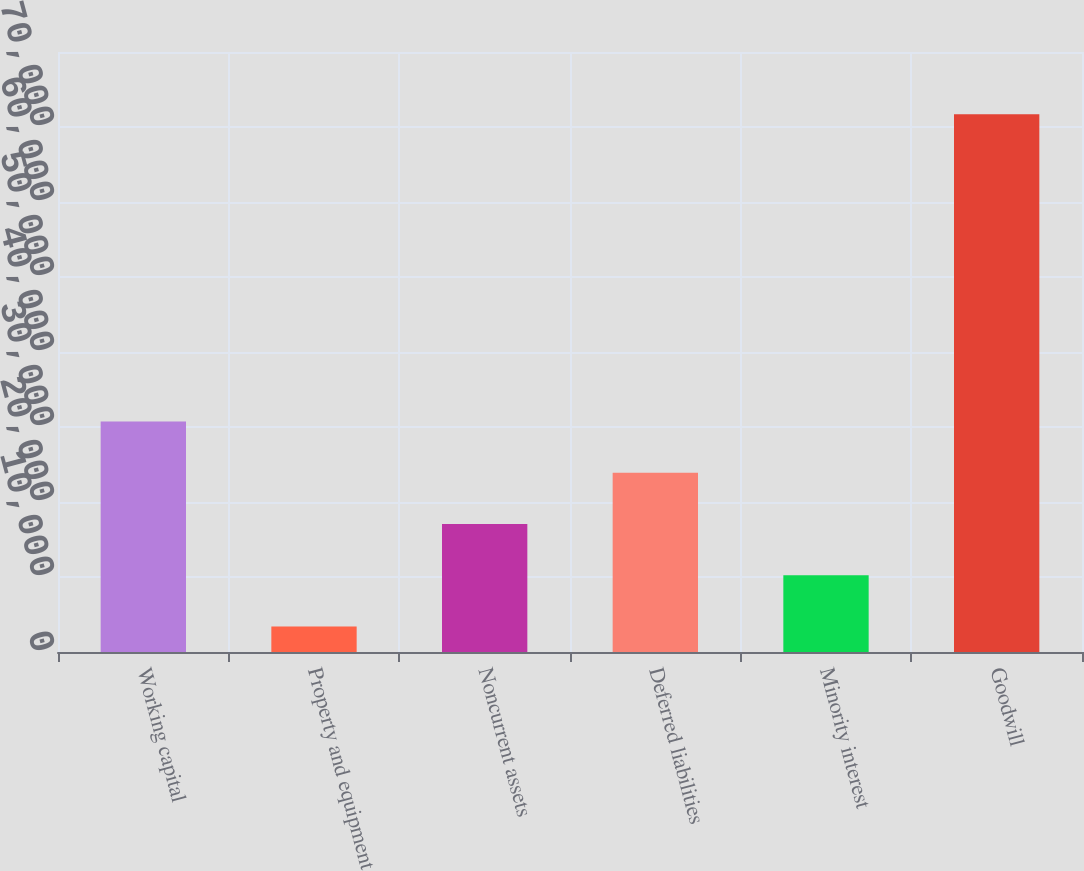Convert chart to OTSL. <chart><loc_0><loc_0><loc_500><loc_500><bar_chart><fcel>Working capital<fcel>Property and equipment<fcel>Noncurrent assets<fcel>Deferred liabilities<fcel>Minority interest<fcel>Goodwill<nl><fcel>30728.4<fcel>3414<fcel>17071.2<fcel>23899.8<fcel>10242.6<fcel>71700<nl></chart> 